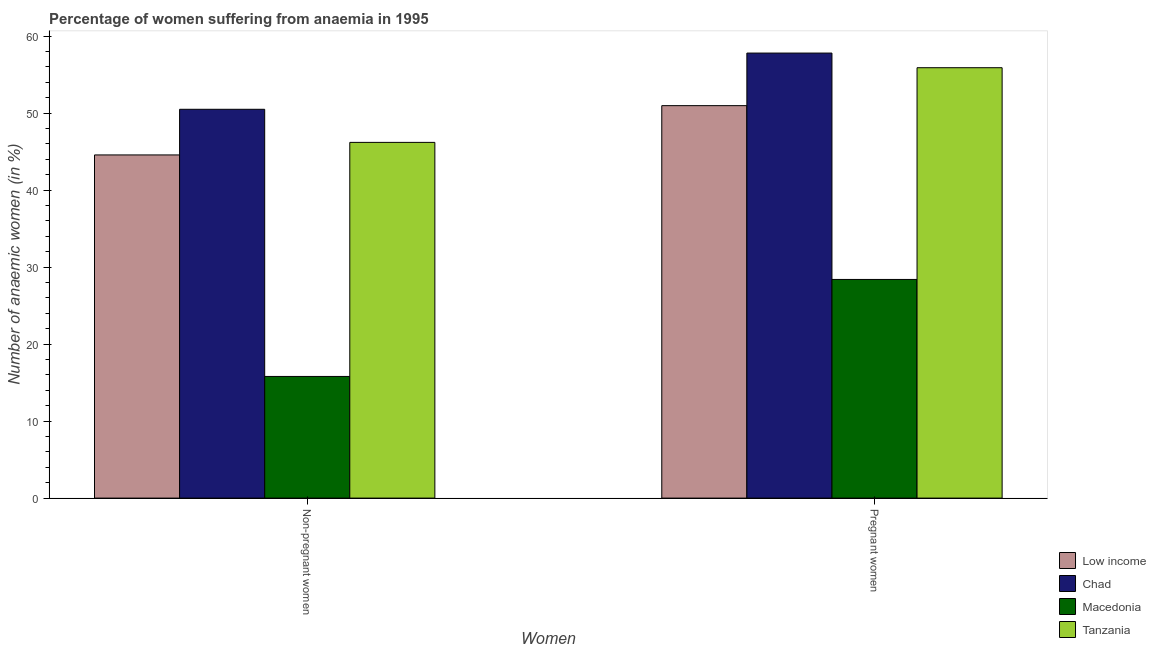Are the number of bars per tick equal to the number of legend labels?
Your response must be concise. Yes. How many bars are there on the 1st tick from the right?
Provide a succinct answer. 4. What is the label of the 2nd group of bars from the left?
Offer a very short reply. Pregnant women. What is the percentage of pregnant anaemic women in Chad?
Provide a short and direct response. 57.8. Across all countries, what is the maximum percentage of non-pregnant anaemic women?
Offer a very short reply. 50.5. Across all countries, what is the minimum percentage of pregnant anaemic women?
Your answer should be compact. 28.4. In which country was the percentage of non-pregnant anaemic women maximum?
Offer a very short reply. Chad. In which country was the percentage of non-pregnant anaemic women minimum?
Give a very brief answer. Macedonia. What is the total percentage of non-pregnant anaemic women in the graph?
Offer a terse response. 157.07. What is the difference between the percentage of non-pregnant anaemic women in Low income and that in Tanzania?
Make the answer very short. -1.63. What is the difference between the percentage of pregnant anaemic women in Low income and the percentage of non-pregnant anaemic women in Macedonia?
Your answer should be very brief. 35.17. What is the average percentage of pregnant anaemic women per country?
Your response must be concise. 48.27. What is the difference between the percentage of non-pregnant anaemic women and percentage of pregnant anaemic women in Chad?
Your answer should be very brief. -7.3. In how many countries, is the percentage of non-pregnant anaemic women greater than 50 %?
Give a very brief answer. 1. What is the ratio of the percentage of non-pregnant anaemic women in Tanzania to that in Macedonia?
Give a very brief answer. 2.92. In how many countries, is the percentage of pregnant anaemic women greater than the average percentage of pregnant anaemic women taken over all countries?
Provide a succinct answer. 3. What does the 1st bar from the left in Non-pregnant women represents?
Offer a terse response. Low income. What does the 2nd bar from the right in Non-pregnant women represents?
Provide a short and direct response. Macedonia. How many bars are there?
Your answer should be compact. 8. How many legend labels are there?
Ensure brevity in your answer.  4. How are the legend labels stacked?
Your answer should be very brief. Vertical. What is the title of the graph?
Provide a short and direct response. Percentage of women suffering from anaemia in 1995. What is the label or title of the X-axis?
Your response must be concise. Women. What is the label or title of the Y-axis?
Your answer should be compact. Number of anaemic women (in %). What is the Number of anaemic women (in %) in Low income in Non-pregnant women?
Your response must be concise. 44.57. What is the Number of anaemic women (in %) in Chad in Non-pregnant women?
Your response must be concise. 50.5. What is the Number of anaemic women (in %) in Macedonia in Non-pregnant women?
Keep it short and to the point. 15.8. What is the Number of anaemic women (in %) in Tanzania in Non-pregnant women?
Keep it short and to the point. 46.2. What is the Number of anaemic women (in %) in Low income in Pregnant women?
Make the answer very short. 50.97. What is the Number of anaemic women (in %) in Chad in Pregnant women?
Your answer should be very brief. 57.8. What is the Number of anaemic women (in %) of Macedonia in Pregnant women?
Your response must be concise. 28.4. What is the Number of anaemic women (in %) of Tanzania in Pregnant women?
Provide a succinct answer. 55.9. Across all Women, what is the maximum Number of anaemic women (in %) in Low income?
Provide a succinct answer. 50.97. Across all Women, what is the maximum Number of anaemic women (in %) of Chad?
Offer a terse response. 57.8. Across all Women, what is the maximum Number of anaemic women (in %) in Macedonia?
Give a very brief answer. 28.4. Across all Women, what is the maximum Number of anaemic women (in %) in Tanzania?
Keep it short and to the point. 55.9. Across all Women, what is the minimum Number of anaemic women (in %) of Low income?
Provide a short and direct response. 44.57. Across all Women, what is the minimum Number of anaemic women (in %) of Chad?
Provide a succinct answer. 50.5. Across all Women, what is the minimum Number of anaemic women (in %) of Tanzania?
Keep it short and to the point. 46.2. What is the total Number of anaemic women (in %) of Low income in the graph?
Ensure brevity in your answer.  95.54. What is the total Number of anaemic women (in %) in Chad in the graph?
Your answer should be compact. 108.3. What is the total Number of anaemic women (in %) of Macedonia in the graph?
Provide a succinct answer. 44.2. What is the total Number of anaemic women (in %) of Tanzania in the graph?
Offer a terse response. 102.1. What is the difference between the Number of anaemic women (in %) in Low income in Non-pregnant women and that in Pregnant women?
Ensure brevity in your answer.  -6.4. What is the difference between the Number of anaemic women (in %) of Tanzania in Non-pregnant women and that in Pregnant women?
Offer a very short reply. -9.7. What is the difference between the Number of anaemic women (in %) in Low income in Non-pregnant women and the Number of anaemic women (in %) in Chad in Pregnant women?
Keep it short and to the point. -13.23. What is the difference between the Number of anaemic women (in %) of Low income in Non-pregnant women and the Number of anaemic women (in %) of Macedonia in Pregnant women?
Offer a terse response. 16.17. What is the difference between the Number of anaemic women (in %) of Low income in Non-pregnant women and the Number of anaemic women (in %) of Tanzania in Pregnant women?
Offer a terse response. -11.33. What is the difference between the Number of anaemic women (in %) of Chad in Non-pregnant women and the Number of anaemic women (in %) of Macedonia in Pregnant women?
Your answer should be very brief. 22.1. What is the difference between the Number of anaemic women (in %) in Macedonia in Non-pregnant women and the Number of anaemic women (in %) in Tanzania in Pregnant women?
Provide a succinct answer. -40.1. What is the average Number of anaemic women (in %) in Low income per Women?
Provide a succinct answer. 47.77. What is the average Number of anaemic women (in %) in Chad per Women?
Your answer should be compact. 54.15. What is the average Number of anaemic women (in %) of Macedonia per Women?
Ensure brevity in your answer.  22.1. What is the average Number of anaemic women (in %) in Tanzania per Women?
Your response must be concise. 51.05. What is the difference between the Number of anaemic women (in %) of Low income and Number of anaemic women (in %) of Chad in Non-pregnant women?
Offer a terse response. -5.93. What is the difference between the Number of anaemic women (in %) in Low income and Number of anaemic women (in %) in Macedonia in Non-pregnant women?
Ensure brevity in your answer.  28.77. What is the difference between the Number of anaemic women (in %) of Low income and Number of anaemic women (in %) of Tanzania in Non-pregnant women?
Provide a succinct answer. -1.63. What is the difference between the Number of anaemic women (in %) of Chad and Number of anaemic women (in %) of Macedonia in Non-pregnant women?
Ensure brevity in your answer.  34.7. What is the difference between the Number of anaemic women (in %) in Chad and Number of anaemic women (in %) in Tanzania in Non-pregnant women?
Provide a short and direct response. 4.3. What is the difference between the Number of anaemic women (in %) of Macedonia and Number of anaemic women (in %) of Tanzania in Non-pregnant women?
Your response must be concise. -30.4. What is the difference between the Number of anaemic women (in %) of Low income and Number of anaemic women (in %) of Chad in Pregnant women?
Ensure brevity in your answer.  -6.83. What is the difference between the Number of anaemic women (in %) of Low income and Number of anaemic women (in %) of Macedonia in Pregnant women?
Your answer should be very brief. 22.57. What is the difference between the Number of anaemic women (in %) of Low income and Number of anaemic women (in %) of Tanzania in Pregnant women?
Ensure brevity in your answer.  -4.93. What is the difference between the Number of anaemic women (in %) in Chad and Number of anaemic women (in %) in Macedonia in Pregnant women?
Ensure brevity in your answer.  29.4. What is the difference between the Number of anaemic women (in %) in Macedonia and Number of anaemic women (in %) in Tanzania in Pregnant women?
Provide a short and direct response. -27.5. What is the ratio of the Number of anaemic women (in %) in Low income in Non-pregnant women to that in Pregnant women?
Your answer should be very brief. 0.87. What is the ratio of the Number of anaemic women (in %) in Chad in Non-pregnant women to that in Pregnant women?
Keep it short and to the point. 0.87. What is the ratio of the Number of anaemic women (in %) of Macedonia in Non-pregnant women to that in Pregnant women?
Give a very brief answer. 0.56. What is the ratio of the Number of anaemic women (in %) of Tanzania in Non-pregnant women to that in Pregnant women?
Your answer should be very brief. 0.83. What is the difference between the highest and the second highest Number of anaemic women (in %) in Low income?
Make the answer very short. 6.4. What is the difference between the highest and the lowest Number of anaemic women (in %) in Low income?
Keep it short and to the point. 6.4. What is the difference between the highest and the lowest Number of anaemic women (in %) in Macedonia?
Your answer should be very brief. 12.6. 